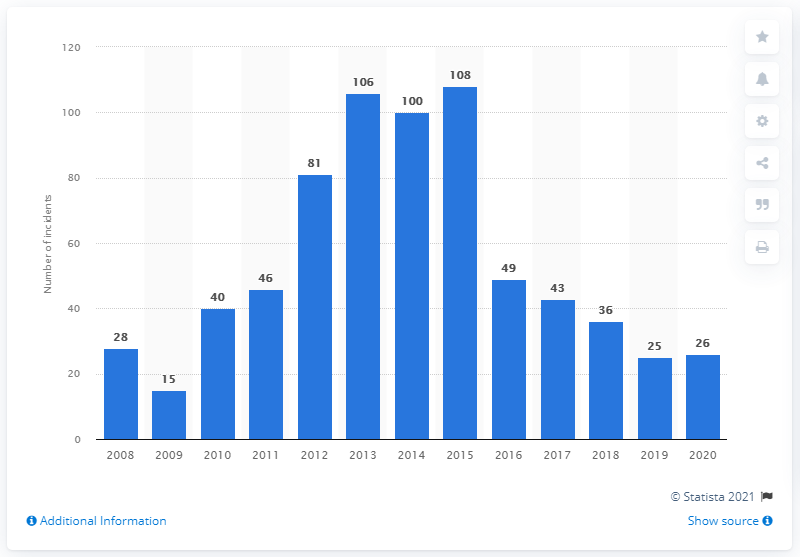Give some essential details in this illustration. There were 26 actual and attempted piracy attacks in Indonesia in 2020. 